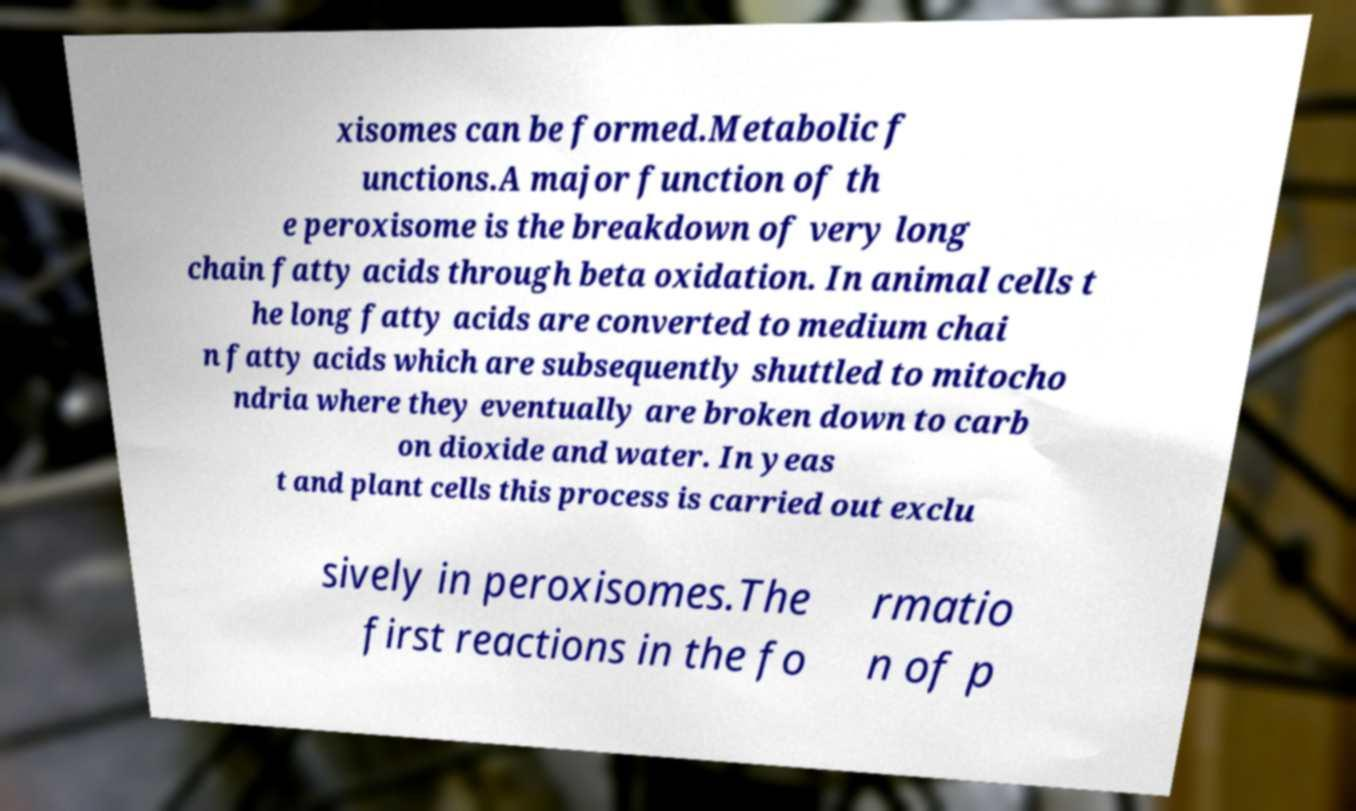Can you read and provide the text displayed in the image?This photo seems to have some interesting text. Can you extract and type it out for me? xisomes can be formed.Metabolic f unctions.A major function of th e peroxisome is the breakdown of very long chain fatty acids through beta oxidation. In animal cells t he long fatty acids are converted to medium chai n fatty acids which are subsequently shuttled to mitocho ndria where they eventually are broken down to carb on dioxide and water. In yeas t and plant cells this process is carried out exclu sively in peroxisomes.The first reactions in the fo rmatio n of p 